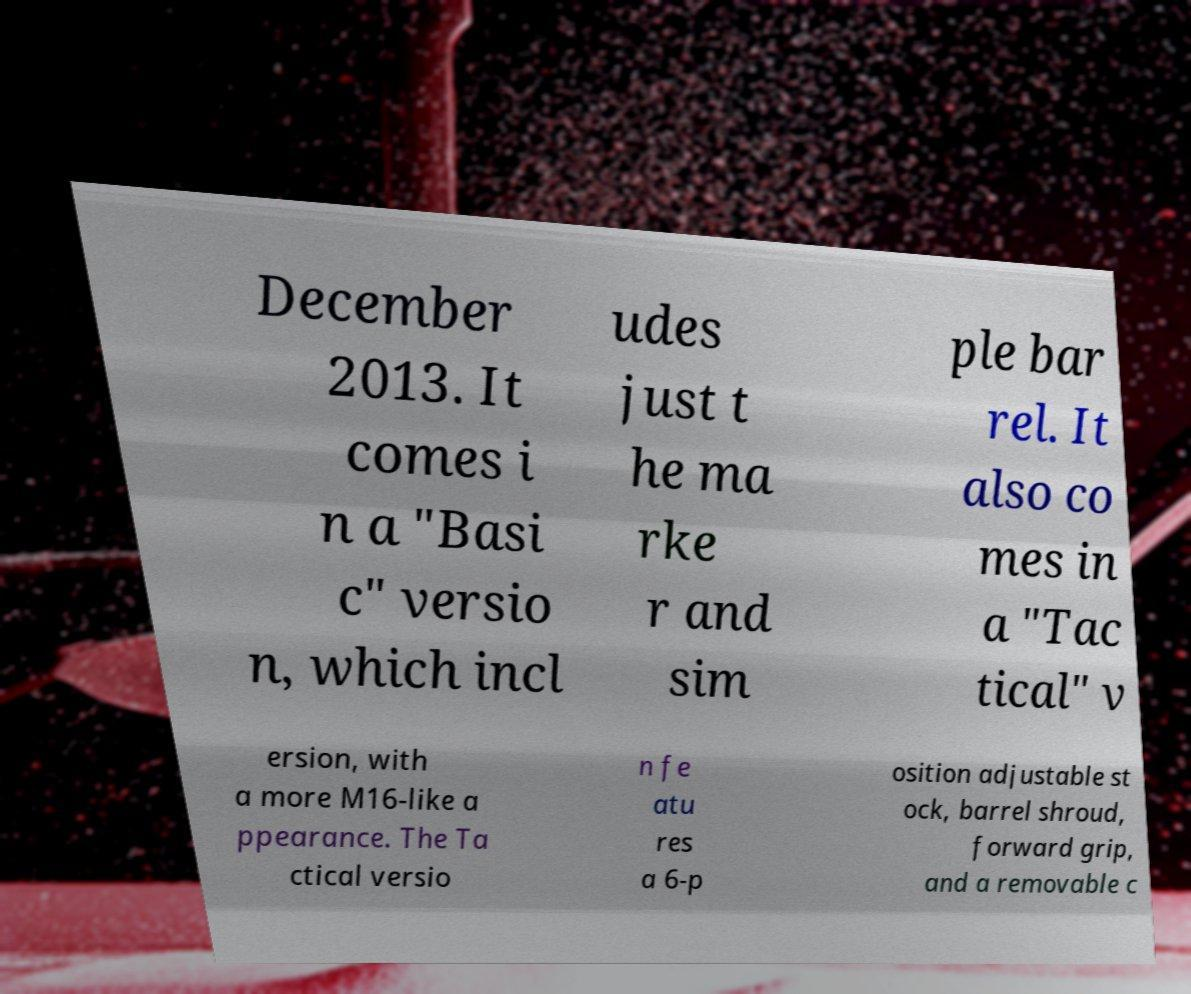Could you extract and type out the text from this image? December 2013. It comes i n a "Basi c" versio n, which incl udes just t he ma rke r and sim ple bar rel. It also co mes in a "Tac tical" v ersion, with a more M16-like a ppearance. The Ta ctical versio n fe atu res a 6-p osition adjustable st ock, barrel shroud, forward grip, and a removable c 